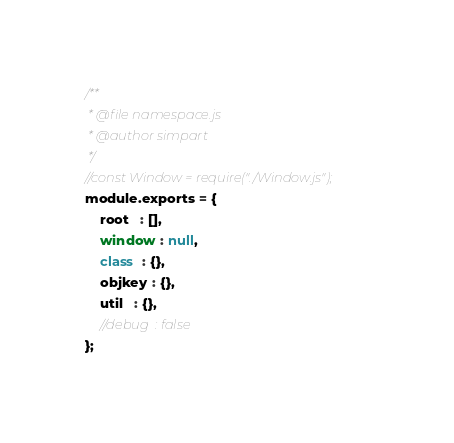Convert code to text. <code><loc_0><loc_0><loc_500><loc_500><_JavaScript_>/**
 * @file namespace.js
 * @author simpart
 */
//const Window = require("./Window.js");
module.exports = {
    root   : [],
    window : null,
    class  : {},
    objkey : {},
    util   : {},
    //debug  : false
};
</code> 